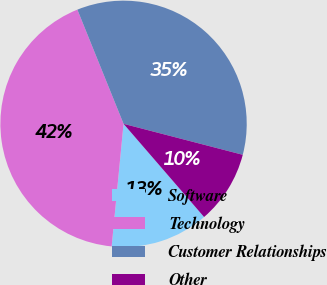Convert chart to OTSL. <chart><loc_0><loc_0><loc_500><loc_500><pie_chart><fcel>Software<fcel>Technology<fcel>Customer Relationships<fcel>Other<nl><fcel>12.88%<fcel>42.34%<fcel>35.16%<fcel>9.61%<nl></chart> 